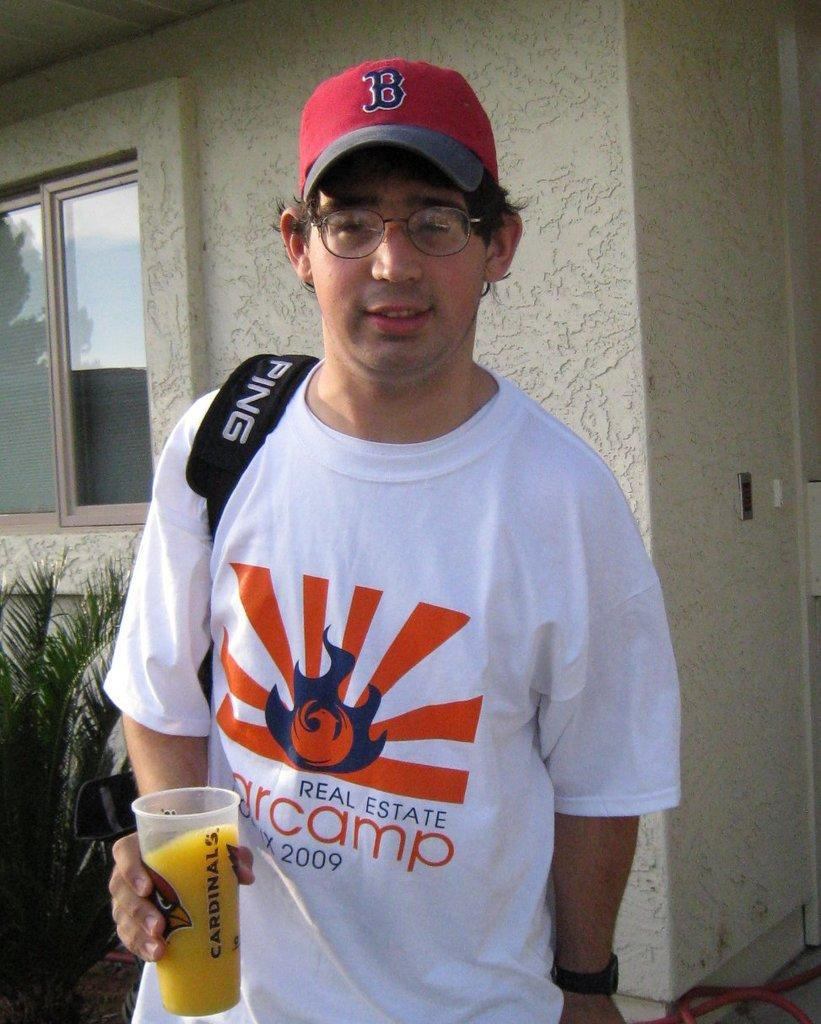<image>
Give a short and clear explanation of the subsequent image. Baseball fan posing in front of building wearing a Boston hat. 